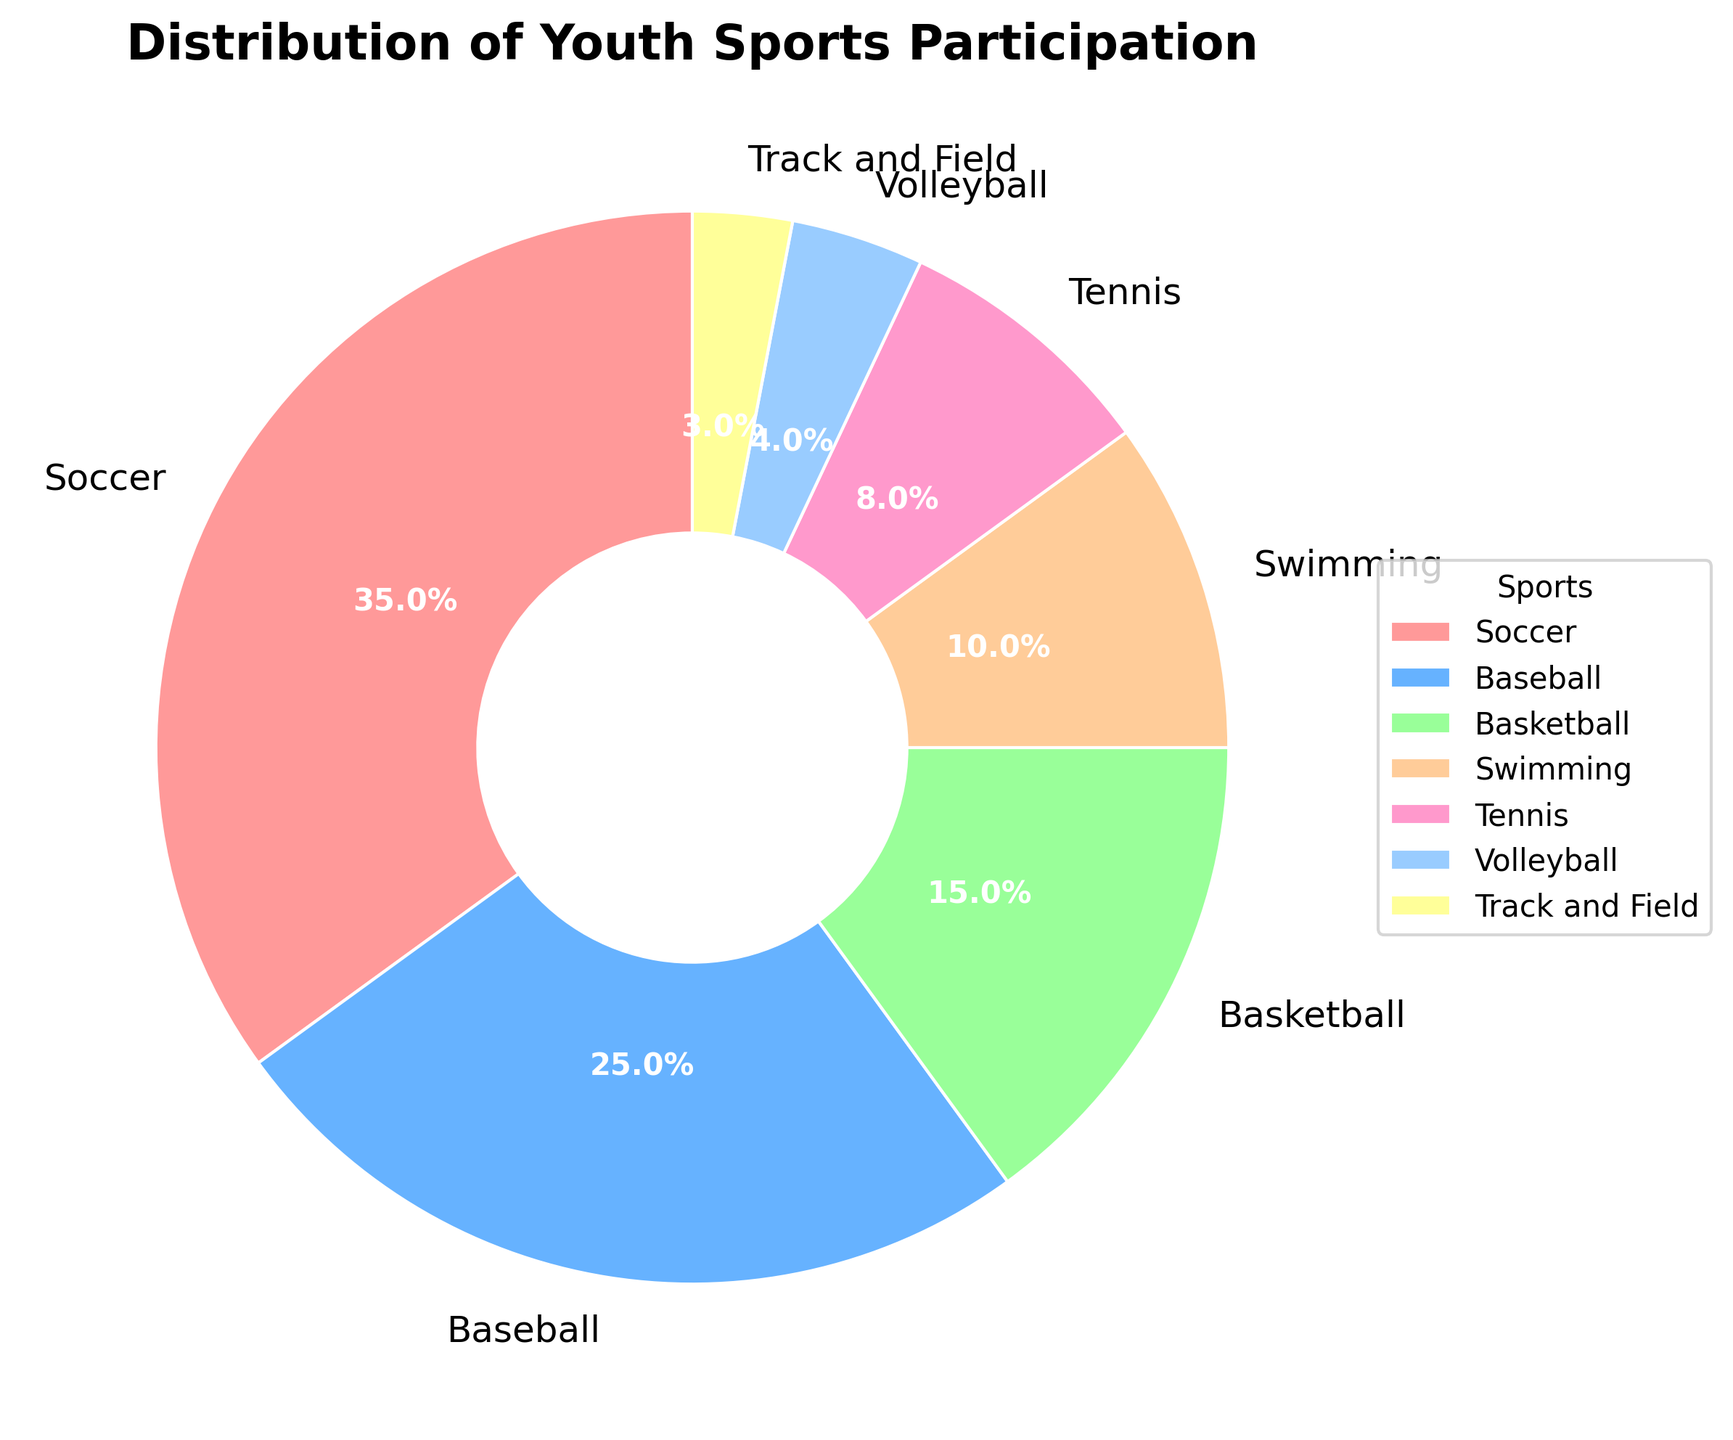What's the total percentage of youth participation for Basketball and Tennis combined? To find the total percentage of youth participation for Basketball and Tennis, add their individual percentages together: 15% (Basketball) + 8% (Tennis) = 23%.
Answer: 23% Which sport has the lowest participation rate? Look at the section of the pie chart with the smallest segment, which represents Track and Field at 3%.
Answer: Track and Field Which sport has higher participation, Swimming or Volleyball? Compare the segments of the pie chart for Swimming (10%) and Volleyball (4%). Swimming has a higher percentage than Volleyball.
Answer: Swimming What is the difference in participation percentage between the sport with the highest participation and the sport with the lowest participation? Soccer has the highest participation at 35%, and Track and Field has the lowest at 3%. Calculate the difference: 35% - 3% = 32%.
Answer: 32% What percentage of youth participate in sports other than Soccer? To find the percentage of youth participating in sports other than Soccer, subtract Soccer's percentage from 100%: 100% - 35% = 65%.
Answer: 65% Are there more children participating in Tennis or in Track and Field and Volleyball combined? Compare Tennis (8%) with the sum of Track and Field (3%) and Volleyball (4%): 3% + 4% = 7%. Tennis has a higher percentage at 8% compared to the combined total of Track and Field and Volleyball at 7%.
Answer: Tennis If Basketball and Baseball are combined into one category, would it have more participation than Soccer? Combine Basketball (15%) and Baseball (25%) to see if it would surpass Soccer: 15% + 25% = 40%. Since 40% is greater than Soccer’s 35%, the combined category would have more participation.
Answer: Yes Is the percentage of children participating in Swimming more than half of those participating in Soccer? Compare Swimming’s 10% with half of Soccer's 35%, which is 17.5% (35% / 2). Since 10% is less than 17.5%, the participation in Swimming is not more than half of Soccer's.
Answer: No What is the sum of the participation percentages of all the sports with less than 10% participation each? Add the percentages of Volleyball (4%), Track and Field (3%), and Tennis (8%): 4% + 3% + 8% = 15%.
Answer: 15% Which color is used to represent Volleyball in the chart? Identify the color associated with Volleyball's segment in the pie chart, which in this case is a light blue shade.
Answer: light blue 